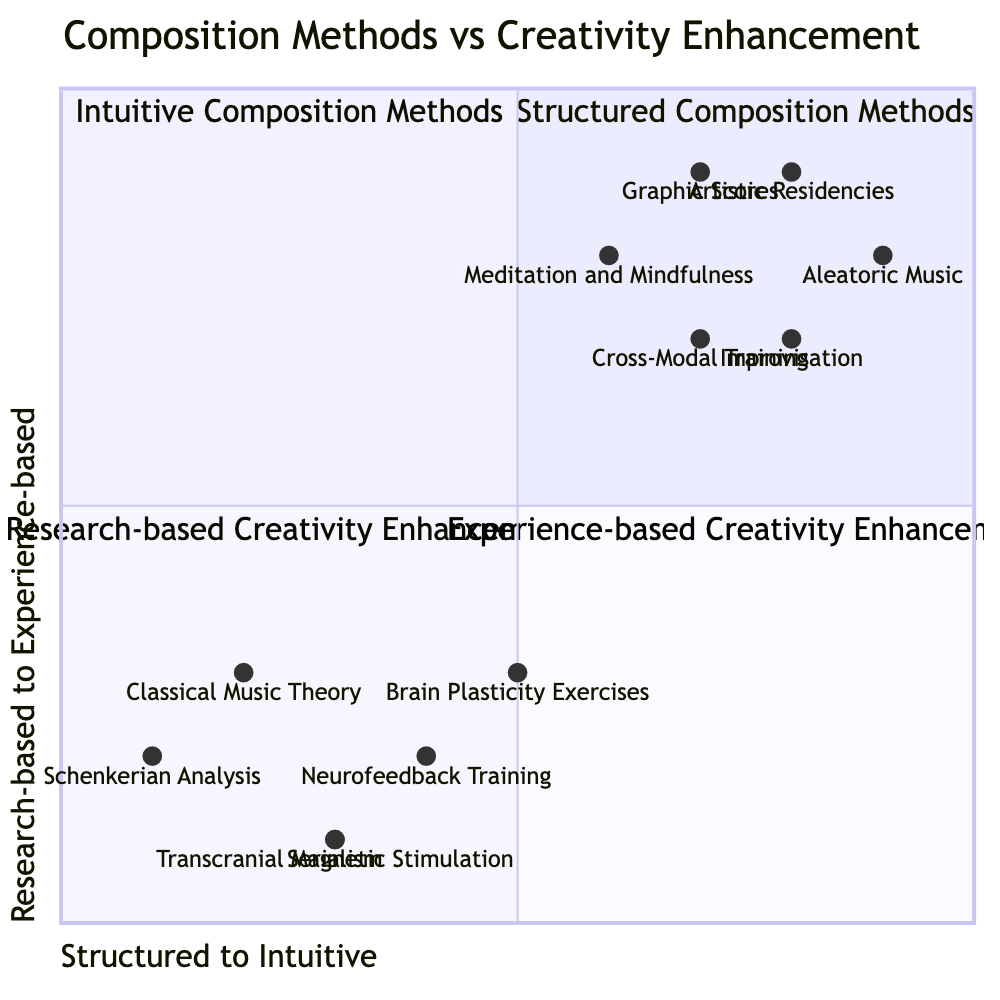What are the elements in the Structured Composition Methods quadrant? The Structured Composition Methods quadrant includes three elements: Classical Music Theory, Schenkerian Analysis, and Serialism. I can identify these elements as listed under the Q1 section in the diagram.
Answer: Classical Music Theory, Schenkerian Analysis, Serialism Which creativity enhancement technique is closest to the Research-based quadrant? The technique that is closest to the Research-based quadrant is Neurofeedback Training, which is positioned at coordinates [0.4, 0.2]. This means it is towards the structured side (left) and more research-based (lower).
Answer: Neurofeedback Training How many elements are in the Experience-based Creativity Enhancement quadrant? The Experience-based Creativity Enhancement quadrant contains three elements: Meditation and Mindfulness, Cross-Modal Training, and Artistic Residencies, as indicated in the Q4 section of the diagram.
Answer: Three Which composition method is the most intuitive based on its position? Aleatoric Music is the most intuitive method, positioned at [0.9, 0.8], indicating it is farthest to the right (intuitive) and higher up (experience-based) within its quadrant.
Answer: Aleatoric Music Where is Serialism located in the diagram? Serialism is located at the coordinates [0.3, 0.1], which indicates it is in the structured quadrant, closer to the bottom part (research-based). I deduce this by referencing its specific position on the diagram.
Answer: [0.3, 0.1] Which technique combines both research-based and experience-based elements? Brain Plasticity Exercises can be inferred to combine both research-based and experience-based elements, positioned at [0.5, 0.3], which is somewhat in between the two quadrants. This requires analyzing its position relative to the quadrants.
Answer: Brain Plasticity Exercises What is the title of the Intuitive Composition Methods quadrant? The title of the Intuitive Composition Methods quadrant, which encompasses various intuitive elements for composition, is "Intuitive Composition Methods," as found in the Q2 section of the diagram.
Answer: Intuitive Composition Methods How does Improvisation relate to the overall structure of the diagram? Improvisation, with coordinates [0.8, 0.7], indicates it is heavily weighted towards intuitive methods while still considering experiential aspects, thus showing a balance of intuitive and experience-based creativity. This relationship is visible through its position near the high points of the diagram.
Answer: Intuitive and experience-based What are the coordinates of Meditation and Mindfulness? Meditation and Mindfulness is located at coordinates [0.6, 0.8] in the diagram, indicating its placement within the Experience-based Creativity Enhancement quadrant.
Answer: [0.6, 0.8] 